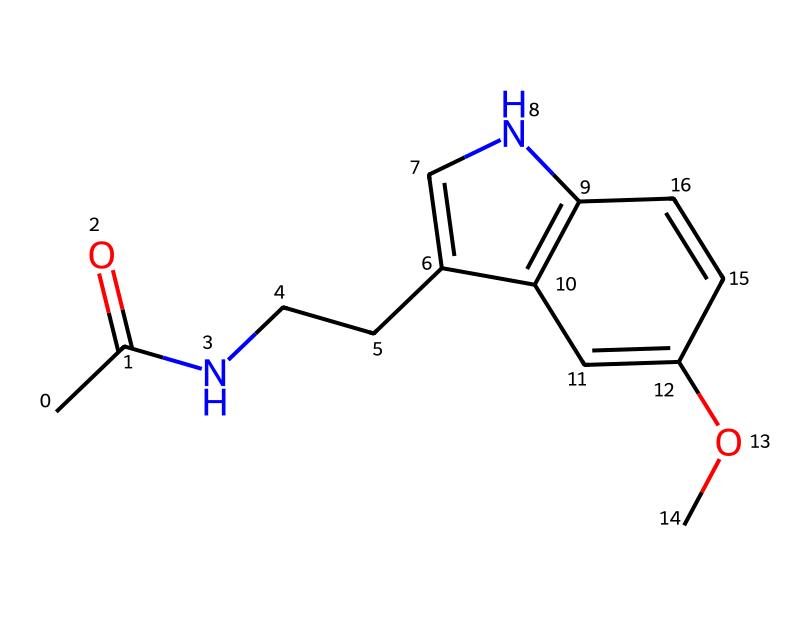What is the molecular formula of melatonin? To find the molecular formula, we can count the number of each type of atom present in the structure. By analyzing the SMILES representation, we see that there are 13 carbon (C) atoms, 16 hydrogen (H) atoms, 1 nitrogen (N) atom, and 2 oxygen (O) atoms, leading to the formula C13H16N2O2.
Answer: C13H16N2O2 How many rings are present in the structure of melatonin? Observing the chemical structure, we can identify that there are two cyclic groups (rings) connected to each other within the molecule. This is determined by the presence of double bonds and specific bonding patterns typical of cyclic compounds.
Answer: 2 What functional groups are found in melatonin? The functional groups can be identified by looking for specific atoms characteristic of functional groups. In melatonin, we can see an acetyl group (–C(=O)CH3) and an ether group (–O–). These indicate the presence of carbonyl and ether functional groups.
Answer: carbonyl and ether Which atom is responsible for melatonin's biological activity? The nitrogen atom in the structure is crucial for melatonin's biological activity. This nitrogen is part of the indole structure, which allows melatonin to bind to specific receptors in the brain, affecting sleep regulation.
Answer: nitrogen Is melatonin a hypervalent compound? To determine if melatonin is a hypervalent compound, we need to check the valence of the central atoms. The carbon atoms in this molecule do not exceed the typical tetravalence (four bonds). Therefore, melatonin does not qualify as a hypervalent compound.
Answer: no How many double bonds are present in the chemical structure of melatonin? By analyzing each bond in the structure, we can identify the presence of double bonds. In melatonin, there are four double bonds (C=C and C=O) that connect various parts of the molecule.
Answer: 4 